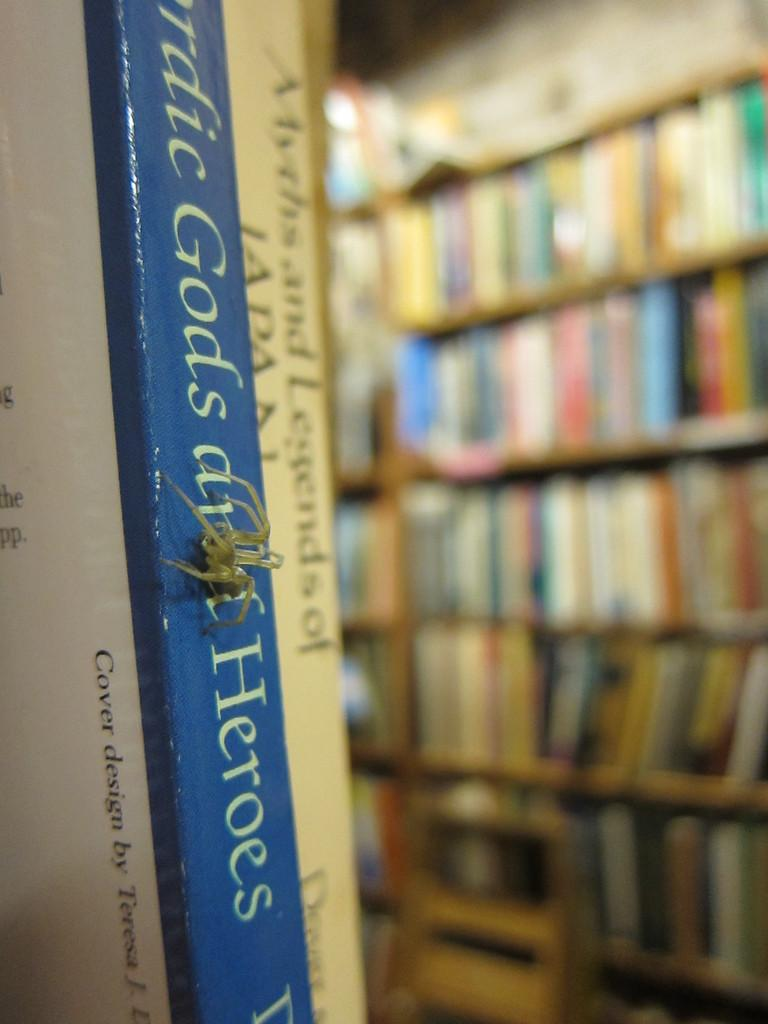Provide a one-sentence caption for the provided image. A book has the word heroes on the binding. 